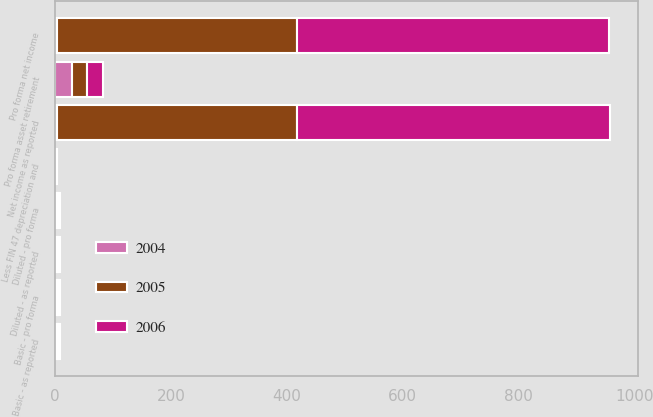Convert chart. <chart><loc_0><loc_0><loc_500><loc_500><stacked_bar_chart><ecel><fcel>Net income as reported<fcel>Less FIN 47 depreciation and<fcel>Pro forma net income<fcel>Basic - as reported<fcel>Basic - pro forma<fcel>Diluted - as reported<fcel>Diluted - pro forma<fcel>Pro forma asset retirement<nl><fcel>2004<fcel>3.16<fcel>1<fcel>3.16<fcel>3.44<fcel>3.53<fcel>3.37<fcel>3.47<fcel>29.3<nl><fcel>2006<fcel>540<fcel>0.9<fcel>539.1<fcel>2.95<fcel>2.94<fcel>2.88<fcel>2.88<fcel>27.6<nl><fcel>2005<fcel>414.9<fcel>0.9<fcel>414<fcel>2.24<fcel>2.23<fcel>2.17<fcel>2.17<fcel>26<nl></chart> 